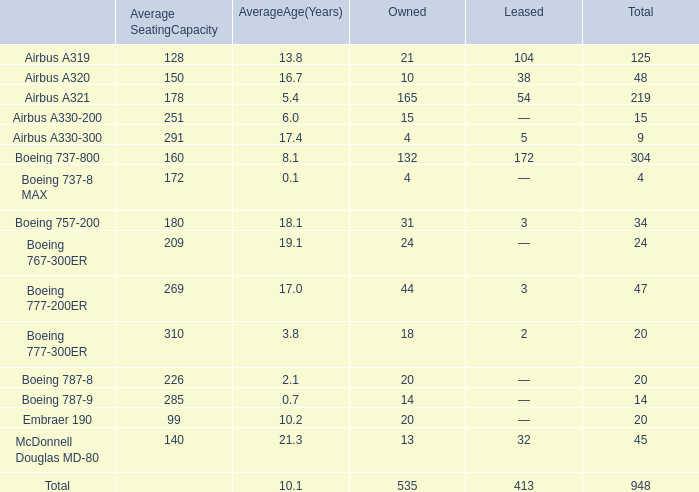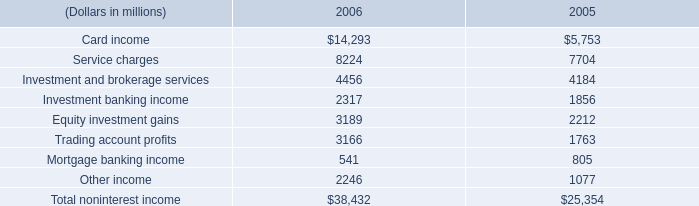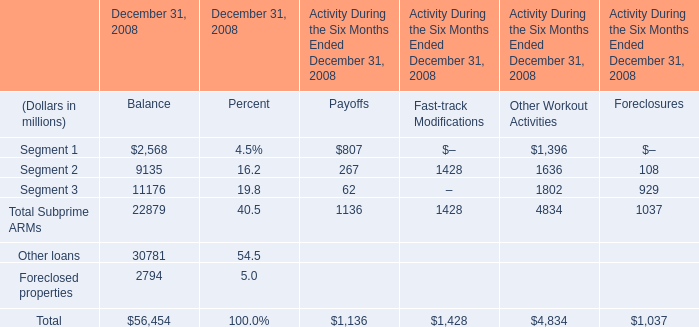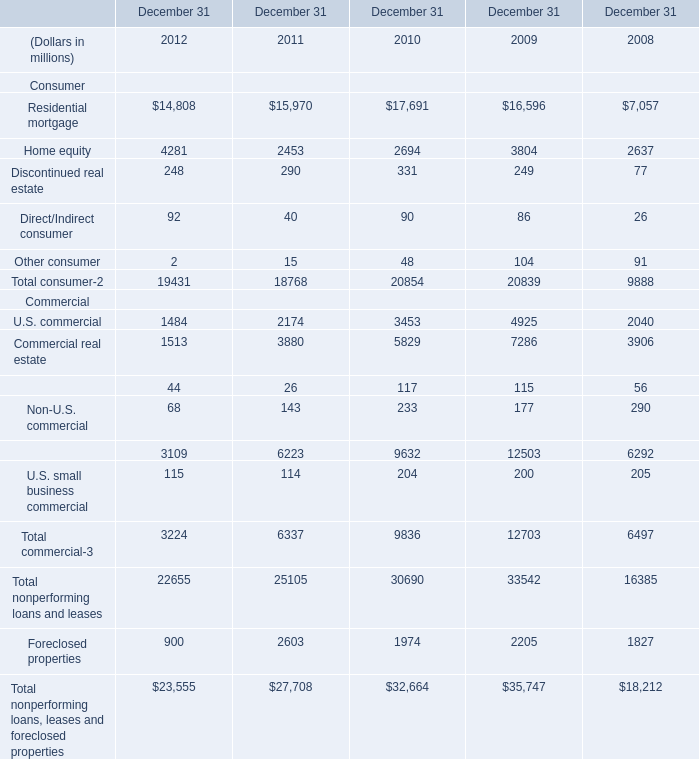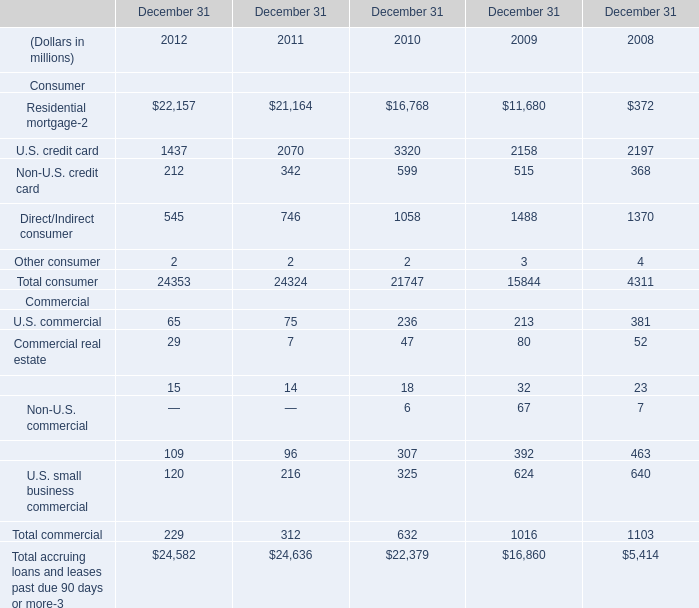What is the total amount of Commercial real estate Commercial of December 31 2010, and Equity investment gains of 2005 ? 
Computations: (5829.0 + 2212.0)
Answer: 8041.0. 